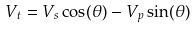Convert formula to latex. <formula><loc_0><loc_0><loc_500><loc_500>V _ { t } = V _ { s } \cos ( \theta ) - V _ { p } \sin ( \theta )</formula> 